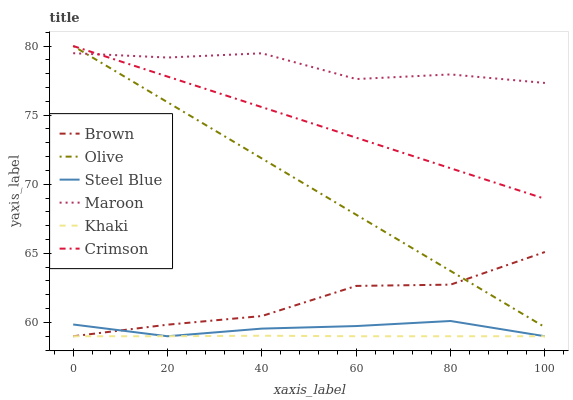Does Steel Blue have the minimum area under the curve?
Answer yes or no. No. Does Steel Blue have the maximum area under the curve?
Answer yes or no. No. Is Khaki the smoothest?
Answer yes or no. No. Is Khaki the roughest?
Answer yes or no. No. Does Maroon have the lowest value?
Answer yes or no. No. Does Steel Blue have the highest value?
Answer yes or no. No. Is Khaki less than Crimson?
Answer yes or no. Yes. Is Maroon greater than Brown?
Answer yes or no. Yes. Does Khaki intersect Crimson?
Answer yes or no. No. 